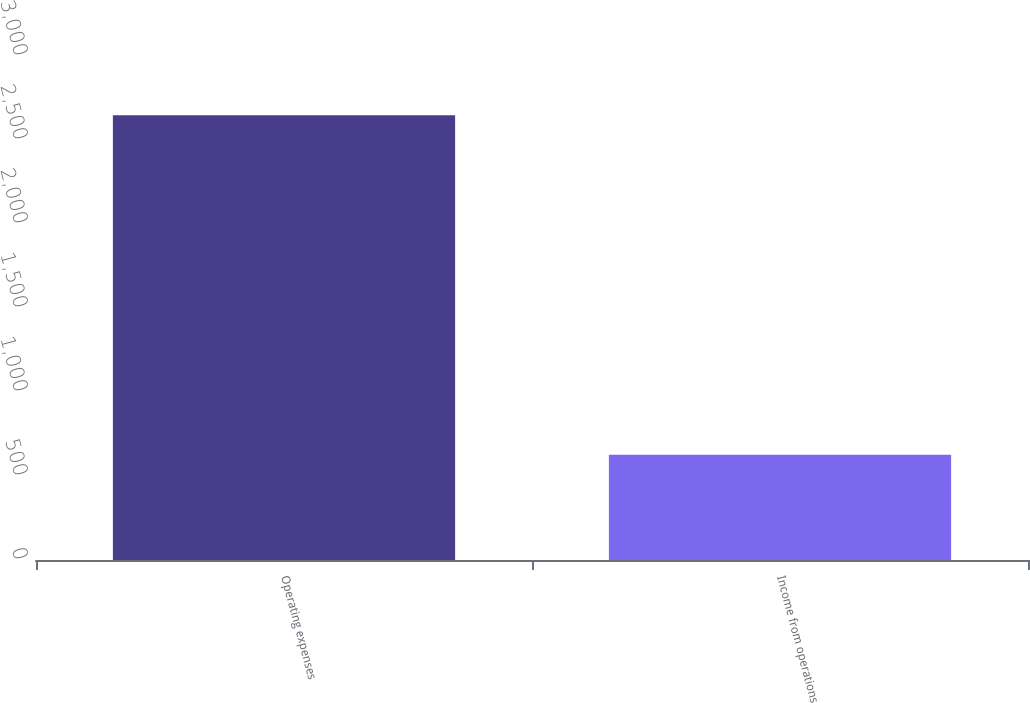Convert chart. <chart><loc_0><loc_0><loc_500><loc_500><bar_chart><fcel>Operating expenses<fcel>Income from operations<nl><fcel>2648<fcel>626<nl></chart> 